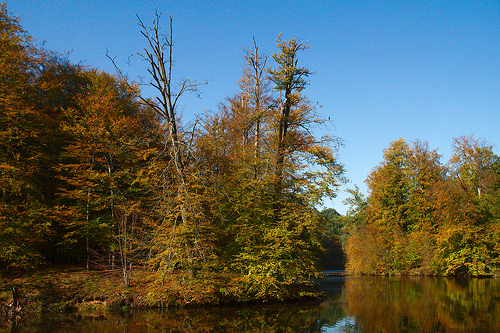<image>
Can you confirm if the trees is in front of the river? No. The trees is not in front of the river. The spatial positioning shows a different relationship between these objects. 